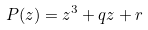<formula> <loc_0><loc_0><loc_500><loc_500>P ( z ) = z ^ { 3 } + q z + r</formula> 